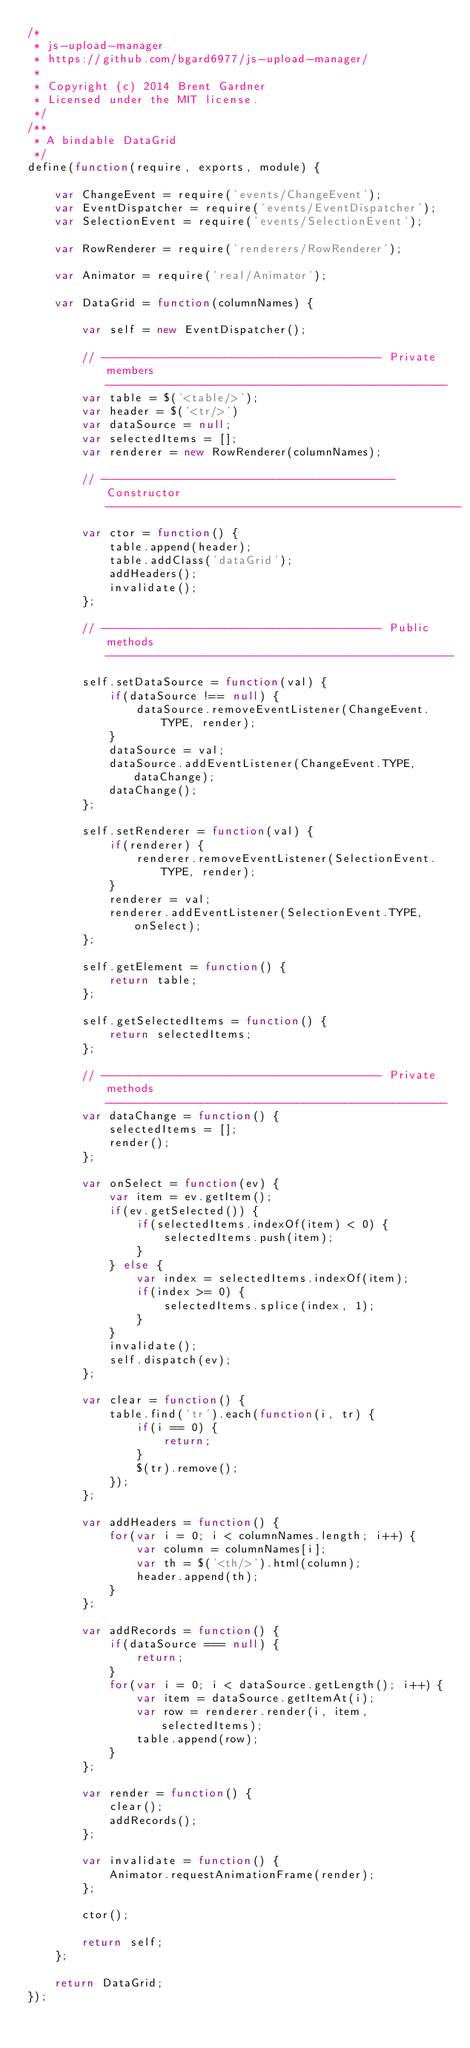<code> <loc_0><loc_0><loc_500><loc_500><_JavaScript_>/*
 * js-upload-manager
 * https://github.com/bgard6977/js-upload-manager/
 *
 * Copyright (c) 2014 Brent Gardner
 * Licensed under the MIT license.
 */
/**
 * A bindable DataGrid
 */
define(function(require, exports, module) {

    var ChangeEvent = require('events/ChangeEvent');
    var EventDispatcher = require('events/EventDispatcher');
    var SelectionEvent = require('events/SelectionEvent');

    var RowRenderer = require('renderers/RowRenderer');

    var Animator = require('real/Animator');

    var DataGrid = function(columnNames) {

        var self = new EventDispatcher();

        // ----------------------------------------- Private members --------------------------------------------------
        var table = $('<table/>');
        var header = $('<tr/>')
        var dataSource = null;
        var selectedItems = [];
        var renderer = new RowRenderer(columnNames);

        // ------------------------------------------- Constructor ----------------------------------------------------
        var ctor = function() {
            table.append(header);
            table.addClass('dataGrid');
            addHeaders();
            invalidate();
        };

        // ----------------------------------------- Public methods ---------------------------------------------------
        self.setDataSource = function(val) {
            if(dataSource !== null) {
                dataSource.removeEventListener(ChangeEvent.TYPE, render);
            }
            dataSource = val;
            dataSource.addEventListener(ChangeEvent.TYPE, dataChange);
            dataChange();
        };

        self.setRenderer = function(val) {
            if(renderer) {
                renderer.removeEventListener(SelectionEvent.TYPE, render);
            }
            renderer = val;
            renderer.addEventListener(SelectionEvent.TYPE, onSelect);
        };

        self.getElement = function() {
            return table;
        };

        self.getSelectedItems = function() {
            return selectedItems;
        };

        // ----------------------------------------- Private methods --------------------------------------------------
        var dataChange = function() {
            selectedItems = [];
            render();
        };

        var onSelect = function(ev) {
            var item = ev.getItem();
            if(ev.getSelected()) {
                if(selectedItems.indexOf(item) < 0) {
                    selectedItems.push(item);
                }
            } else {
                var index = selectedItems.indexOf(item);
                if(index >= 0) {
                    selectedItems.splice(index, 1);
                }
            }
            invalidate();
            self.dispatch(ev);
        };

        var clear = function() {
            table.find('tr').each(function(i, tr) {
                if(i == 0) {
                    return;
                }
                $(tr).remove();
            });
        };

        var addHeaders = function() {
            for(var i = 0; i < columnNames.length; i++) {
                var column = columnNames[i];
                var th = $('<th/>').html(column);
                header.append(th);
            }
        };

        var addRecords = function() {
            if(dataSource === null) {
                return;
            }
            for(var i = 0; i < dataSource.getLength(); i++) {
                var item = dataSource.getItemAt(i);
                var row = renderer.render(i, item, selectedItems);
                table.append(row);
            }
        };

        var render = function() {
            clear();
            addRecords();
        };

        var invalidate = function() {
            Animator.requestAnimationFrame(render);
        };

        ctor();

        return self;
    };

    return DataGrid;
});</code> 